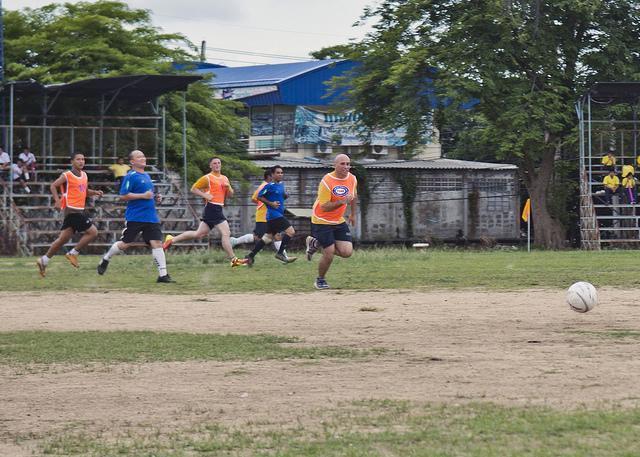How many signs are in the background?
Give a very brief answer. 1. How many dogs are in the photo?
Give a very brief answer. 0. How many people can be seen?
Give a very brief answer. 4. 